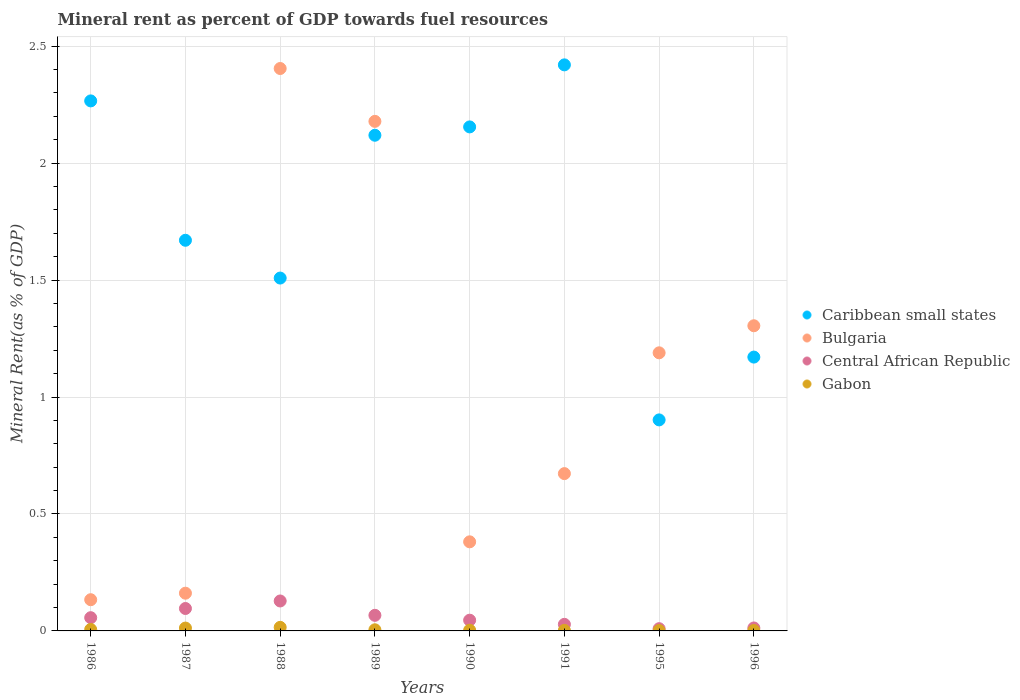How many different coloured dotlines are there?
Provide a succinct answer. 4. Is the number of dotlines equal to the number of legend labels?
Ensure brevity in your answer.  Yes. What is the mineral rent in Bulgaria in 1991?
Offer a terse response. 0.67. Across all years, what is the maximum mineral rent in Bulgaria?
Your response must be concise. 2.4. Across all years, what is the minimum mineral rent in Bulgaria?
Give a very brief answer. 0.13. What is the total mineral rent in Central African Republic in the graph?
Ensure brevity in your answer.  0.44. What is the difference between the mineral rent in Bulgaria in 1988 and that in 1991?
Give a very brief answer. 1.73. What is the difference between the mineral rent in Bulgaria in 1988 and the mineral rent in Gabon in 1996?
Ensure brevity in your answer.  2.4. What is the average mineral rent in Gabon per year?
Make the answer very short. 0.01. In the year 1989, what is the difference between the mineral rent in Gabon and mineral rent in Central African Republic?
Your answer should be compact. -0.06. In how many years, is the mineral rent in Gabon greater than 1.3 %?
Make the answer very short. 0. What is the ratio of the mineral rent in Caribbean small states in 1995 to that in 1996?
Ensure brevity in your answer.  0.77. Is the mineral rent in Caribbean small states in 1990 less than that in 1996?
Your response must be concise. No. What is the difference between the highest and the second highest mineral rent in Central African Republic?
Keep it short and to the point. 0.03. What is the difference between the highest and the lowest mineral rent in Central African Republic?
Your answer should be very brief. 0.12. Is it the case that in every year, the sum of the mineral rent in Bulgaria and mineral rent in Central African Republic  is greater than the mineral rent in Gabon?
Ensure brevity in your answer.  Yes. Is the mineral rent in Gabon strictly less than the mineral rent in Bulgaria over the years?
Provide a succinct answer. Yes. How many years are there in the graph?
Your response must be concise. 8. What is the difference between two consecutive major ticks on the Y-axis?
Give a very brief answer. 0.5. Are the values on the major ticks of Y-axis written in scientific E-notation?
Keep it short and to the point. No. Does the graph contain grids?
Offer a terse response. Yes. How many legend labels are there?
Ensure brevity in your answer.  4. How are the legend labels stacked?
Your answer should be very brief. Vertical. What is the title of the graph?
Your answer should be very brief. Mineral rent as percent of GDP towards fuel resources. Does "Yemen, Rep." appear as one of the legend labels in the graph?
Provide a succinct answer. No. What is the label or title of the Y-axis?
Your answer should be very brief. Mineral Rent(as % of GDP). What is the Mineral Rent(as % of GDP) in Caribbean small states in 1986?
Give a very brief answer. 2.27. What is the Mineral Rent(as % of GDP) of Bulgaria in 1986?
Your response must be concise. 0.13. What is the Mineral Rent(as % of GDP) in Central African Republic in 1986?
Your answer should be compact. 0.06. What is the Mineral Rent(as % of GDP) in Gabon in 1986?
Keep it short and to the point. 0.01. What is the Mineral Rent(as % of GDP) in Caribbean small states in 1987?
Make the answer very short. 1.67. What is the Mineral Rent(as % of GDP) in Bulgaria in 1987?
Your answer should be compact. 0.16. What is the Mineral Rent(as % of GDP) in Central African Republic in 1987?
Keep it short and to the point. 0.1. What is the Mineral Rent(as % of GDP) of Gabon in 1987?
Offer a very short reply. 0.01. What is the Mineral Rent(as % of GDP) of Caribbean small states in 1988?
Make the answer very short. 1.51. What is the Mineral Rent(as % of GDP) of Bulgaria in 1988?
Your answer should be very brief. 2.4. What is the Mineral Rent(as % of GDP) in Central African Republic in 1988?
Your answer should be very brief. 0.13. What is the Mineral Rent(as % of GDP) in Gabon in 1988?
Give a very brief answer. 0.02. What is the Mineral Rent(as % of GDP) in Caribbean small states in 1989?
Keep it short and to the point. 2.12. What is the Mineral Rent(as % of GDP) of Bulgaria in 1989?
Give a very brief answer. 2.18. What is the Mineral Rent(as % of GDP) of Central African Republic in 1989?
Your answer should be very brief. 0.07. What is the Mineral Rent(as % of GDP) in Gabon in 1989?
Keep it short and to the point. 0. What is the Mineral Rent(as % of GDP) of Caribbean small states in 1990?
Provide a short and direct response. 2.15. What is the Mineral Rent(as % of GDP) in Bulgaria in 1990?
Your response must be concise. 0.38. What is the Mineral Rent(as % of GDP) in Central African Republic in 1990?
Your response must be concise. 0.05. What is the Mineral Rent(as % of GDP) of Gabon in 1990?
Your response must be concise. 0. What is the Mineral Rent(as % of GDP) of Caribbean small states in 1991?
Offer a very short reply. 2.42. What is the Mineral Rent(as % of GDP) in Bulgaria in 1991?
Provide a succinct answer. 0.67. What is the Mineral Rent(as % of GDP) of Central African Republic in 1991?
Provide a succinct answer. 0.03. What is the Mineral Rent(as % of GDP) of Gabon in 1991?
Provide a succinct answer. 0. What is the Mineral Rent(as % of GDP) of Caribbean small states in 1995?
Your response must be concise. 0.9. What is the Mineral Rent(as % of GDP) in Bulgaria in 1995?
Provide a short and direct response. 1.19. What is the Mineral Rent(as % of GDP) of Central African Republic in 1995?
Keep it short and to the point. 0.01. What is the Mineral Rent(as % of GDP) in Gabon in 1995?
Provide a short and direct response. 0. What is the Mineral Rent(as % of GDP) of Caribbean small states in 1996?
Keep it short and to the point. 1.17. What is the Mineral Rent(as % of GDP) of Bulgaria in 1996?
Ensure brevity in your answer.  1.3. What is the Mineral Rent(as % of GDP) in Central African Republic in 1996?
Your response must be concise. 0.01. What is the Mineral Rent(as % of GDP) of Gabon in 1996?
Give a very brief answer. 0. Across all years, what is the maximum Mineral Rent(as % of GDP) in Caribbean small states?
Ensure brevity in your answer.  2.42. Across all years, what is the maximum Mineral Rent(as % of GDP) in Bulgaria?
Offer a terse response. 2.4. Across all years, what is the maximum Mineral Rent(as % of GDP) in Central African Republic?
Make the answer very short. 0.13. Across all years, what is the maximum Mineral Rent(as % of GDP) of Gabon?
Make the answer very short. 0.02. Across all years, what is the minimum Mineral Rent(as % of GDP) in Caribbean small states?
Your answer should be compact. 0.9. Across all years, what is the minimum Mineral Rent(as % of GDP) of Bulgaria?
Keep it short and to the point. 0.13. Across all years, what is the minimum Mineral Rent(as % of GDP) of Central African Republic?
Keep it short and to the point. 0.01. Across all years, what is the minimum Mineral Rent(as % of GDP) of Gabon?
Give a very brief answer. 0. What is the total Mineral Rent(as % of GDP) of Caribbean small states in the graph?
Ensure brevity in your answer.  14.21. What is the total Mineral Rent(as % of GDP) in Bulgaria in the graph?
Offer a very short reply. 8.43. What is the total Mineral Rent(as % of GDP) in Central African Republic in the graph?
Make the answer very short. 0.44. What is the total Mineral Rent(as % of GDP) in Gabon in the graph?
Make the answer very short. 0.05. What is the difference between the Mineral Rent(as % of GDP) in Caribbean small states in 1986 and that in 1987?
Provide a short and direct response. 0.6. What is the difference between the Mineral Rent(as % of GDP) in Bulgaria in 1986 and that in 1987?
Ensure brevity in your answer.  -0.03. What is the difference between the Mineral Rent(as % of GDP) in Central African Republic in 1986 and that in 1987?
Give a very brief answer. -0.04. What is the difference between the Mineral Rent(as % of GDP) of Gabon in 1986 and that in 1987?
Offer a very short reply. -0.01. What is the difference between the Mineral Rent(as % of GDP) of Caribbean small states in 1986 and that in 1988?
Give a very brief answer. 0.76. What is the difference between the Mineral Rent(as % of GDP) of Bulgaria in 1986 and that in 1988?
Offer a very short reply. -2.27. What is the difference between the Mineral Rent(as % of GDP) in Central African Republic in 1986 and that in 1988?
Ensure brevity in your answer.  -0.07. What is the difference between the Mineral Rent(as % of GDP) of Gabon in 1986 and that in 1988?
Your response must be concise. -0.01. What is the difference between the Mineral Rent(as % of GDP) of Caribbean small states in 1986 and that in 1989?
Your response must be concise. 0.15. What is the difference between the Mineral Rent(as % of GDP) in Bulgaria in 1986 and that in 1989?
Provide a succinct answer. -2.05. What is the difference between the Mineral Rent(as % of GDP) of Central African Republic in 1986 and that in 1989?
Make the answer very short. -0.01. What is the difference between the Mineral Rent(as % of GDP) of Gabon in 1986 and that in 1989?
Offer a terse response. 0. What is the difference between the Mineral Rent(as % of GDP) in Caribbean small states in 1986 and that in 1990?
Keep it short and to the point. 0.11. What is the difference between the Mineral Rent(as % of GDP) in Bulgaria in 1986 and that in 1990?
Offer a terse response. -0.25. What is the difference between the Mineral Rent(as % of GDP) in Central African Republic in 1986 and that in 1990?
Your answer should be very brief. 0.01. What is the difference between the Mineral Rent(as % of GDP) in Gabon in 1986 and that in 1990?
Your answer should be compact. 0. What is the difference between the Mineral Rent(as % of GDP) of Caribbean small states in 1986 and that in 1991?
Offer a terse response. -0.15. What is the difference between the Mineral Rent(as % of GDP) in Bulgaria in 1986 and that in 1991?
Provide a succinct answer. -0.54. What is the difference between the Mineral Rent(as % of GDP) of Central African Republic in 1986 and that in 1991?
Give a very brief answer. 0.03. What is the difference between the Mineral Rent(as % of GDP) in Gabon in 1986 and that in 1991?
Ensure brevity in your answer.  0. What is the difference between the Mineral Rent(as % of GDP) of Caribbean small states in 1986 and that in 1995?
Provide a succinct answer. 1.36. What is the difference between the Mineral Rent(as % of GDP) of Bulgaria in 1986 and that in 1995?
Keep it short and to the point. -1.06. What is the difference between the Mineral Rent(as % of GDP) in Central African Republic in 1986 and that in 1995?
Offer a very short reply. 0.05. What is the difference between the Mineral Rent(as % of GDP) of Gabon in 1986 and that in 1995?
Give a very brief answer. 0. What is the difference between the Mineral Rent(as % of GDP) of Caribbean small states in 1986 and that in 1996?
Give a very brief answer. 1.1. What is the difference between the Mineral Rent(as % of GDP) in Bulgaria in 1986 and that in 1996?
Provide a short and direct response. -1.17. What is the difference between the Mineral Rent(as % of GDP) of Central African Republic in 1986 and that in 1996?
Your answer should be compact. 0.04. What is the difference between the Mineral Rent(as % of GDP) of Gabon in 1986 and that in 1996?
Offer a very short reply. 0. What is the difference between the Mineral Rent(as % of GDP) in Caribbean small states in 1987 and that in 1988?
Your answer should be very brief. 0.16. What is the difference between the Mineral Rent(as % of GDP) in Bulgaria in 1987 and that in 1988?
Keep it short and to the point. -2.24. What is the difference between the Mineral Rent(as % of GDP) of Central African Republic in 1987 and that in 1988?
Your answer should be very brief. -0.03. What is the difference between the Mineral Rent(as % of GDP) of Gabon in 1987 and that in 1988?
Ensure brevity in your answer.  -0. What is the difference between the Mineral Rent(as % of GDP) in Caribbean small states in 1987 and that in 1989?
Give a very brief answer. -0.45. What is the difference between the Mineral Rent(as % of GDP) of Bulgaria in 1987 and that in 1989?
Your answer should be compact. -2.02. What is the difference between the Mineral Rent(as % of GDP) of Central African Republic in 1987 and that in 1989?
Your answer should be very brief. 0.03. What is the difference between the Mineral Rent(as % of GDP) in Gabon in 1987 and that in 1989?
Give a very brief answer. 0.01. What is the difference between the Mineral Rent(as % of GDP) of Caribbean small states in 1987 and that in 1990?
Make the answer very short. -0.48. What is the difference between the Mineral Rent(as % of GDP) of Bulgaria in 1987 and that in 1990?
Provide a succinct answer. -0.22. What is the difference between the Mineral Rent(as % of GDP) in Central African Republic in 1987 and that in 1990?
Make the answer very short. 0.05. What is the difference between the Mineral Rent(as % of GDP) of Gabon in 1987 and that in 1990?
Provide a short and direct response. 0.01. What is the difference between the Mineral Rent(as % of GDP) of Caribbean small states in 1987 and that in 1991?
Offer a very short reply. -0.75. What is the difference between the Mineral Rent(as % of GDP) of Bulgaria in 1987 and that in 1991?
Provide a succinct answer. -0.51. What is the difference between the Mineral Rent(as % of GDP) in Central African Republic in 1987 and that in 1991?
Offer a very short reply. 0.07. What is the difference between the Mineral Rent(as % of GDP) of Gabon in 1987 and that in 1991?
Make the answer very short. 0.01. What is the difference between the Mineral Rent(as % of GDP) in Caribbean small states in 1987 and that in 1995?
Provide a succinct answer. 0.77. What is the difference between the Mineral Rent(as % of GDP) of Bulgaria in 1987 and that in 1995?
Your answer should be compact. -1.03. What is the difference between the Mineral Rent(as % of GDP) of Central African Republic in 1987 and that in 1995?
Give a very brief answer. 0.09. What is the difference between the Mineral Rent(as % of GDP) in Gabon in 1987 and that in 1995?
Your answer should be compact. 0.01. What is the difference between the Mineral Rent(as % of GDP) in Caribbean small states in 1987 and that in 1996?
Provide a short and direct response. 0.5. What is the difference between the Mineral Rent(as % of GDP) in Bulgaria in 1987 and that in 1996?
Your answer should be very brief. -1.14. What is the difference between the Mineral Rent(as % of GDP) of Central African Republic in 1987 and that in 1996?
Your response must be concise. 0.08. What is the difference between the Mineral Rent(as % of GDP) in Gabon in 1987 and that in 1996?
Offer a terse response. 0.01. What is the difference between the Mineral Rent(as % of GDP) in Caribbean small states in 1988 and that in 1989?
Your answer should be very brief. -0.61. What is the difference between the Mineral Rent(as % of GDP) of Bulgaria in 1988 and that in 1989?
Your response must be concise. 0.23. What is the difference between the Mineral Rent(as % of GDP) in Central African Republic in 1988 and that in 1989?
Your response must be concise. 0.06. What is the difference between the Mineral Rent(as % of GDP) in Gabon in 1988 and that in 1989?
Your response must be concise. 0.01. What is the difference between the Mineral Rent(as % of GDP) of Caribbean small states in 1988 and that in 1990?
Offer a very short reply. -0.65. What is the difference between the Mineral Rent(as % of GDP) of Bulgaria in 1988 and that in 1990?
Provide a short and direct response. 2.02. What is the difference between the Mineral Rent(as % of GDP) of Central African Republic in 1988 and that in 1990?
Your response must be concise. 0.08. What is the difference between the Mineral Rent(as % of GDP) in Gabon in 1988 and that in 1990?
Your response must be concise. 0.01. What is the difference between the Mineral Rent(as % of GDP) of Caribbean small states in 1988 and that in 1991?
Your answer should be compact. -0.91. What is the difference between the Mineral Rent(as % of GDP) in Bulgaria in 1988 and that in 1991?
Ensure brevity in your answer.  1.73. What is the difference between the Mineral Rent(as % of GDP) in Central African Republic in 1988 and that in 1991?
Provide a succinct answer. 0.1. What is the difference between the Mineral Rent(as % of GDP) of Gabon in 1988 and that in 1991?
Offer a very short reply. 0.01. What is the difference between the Mineral Rent(as % of GDP) of Caribbean small states in 1988 and that in 1995?
Offer a terse response. 0.61. What is the difference between the Mineral Rent(as % of GDP) of Bulgaria in 1988 and that in 1995?
Provide a succinct answer. 1.22. What is the difference between the Mineral Rent(as % of GDP) of Central African Republic in 1988 and that in 1995?
Ensure brevity in your answer.  0.12. What is the difference between the Mineral Rent(as % of GDP) of Gabon in 1988 and that in 1995?
Give a very brief answer. 0.01. What is the difference between the Mineral Rent(as % of GDP) in Caribbean small states in 1988 and that in 1996?
Make the answer very short. 0.34. What is the difference between the Mineral Rent(as % of GDP) of Bulgaria in 1988 and that in 1996?
Your response must be concise. 1.1. What is the difference between the Mineral Rent(as % of GDP) of Central African Republic in 1988 and that in 1996?
Your answer should be very brief. 0.12. What is the difference between the Mineral Rent(as % of GDP) in Gabon in 1988 and that in 1996?
Your answer should be compact. 0.01. What is the difference between the Mineral Rent(as % of GDP) in Caribbean small states in 1989 and that in 1990?
Keep it short and to the point. -0.04. What is the difference between the Mineral Rent(as % of GDP) of Bulgaria in 1989 and that in 1990?
Make the answer very short. 1.8. What is the difference between the Mineral Rent(as % of GDP) of Central African Republic in 1989 and that in 1990?
Give a very brief answer. 0.02. What is the difference between the Mineral Rent(as % of GDP) in Gabon in 1989 and that in 1990?
Provide a short and direct response. 0. What is the difference between the Mineral Rent(as % of GDP) in Caribbean small states in 1989 and that in 1991?
Keep it short and to the point. -0.3. What is the difference between the Mineral Rent(as % of GDP) in Bulgaria in 1989 and that in 1991?
Offer a very short reply. 1.51. What is the difference between the Mineral Rent(as % of GDP) of Central African Republic in 1989 and that in 1991?
Provide a succinct answer. 0.04. What is the difference between the Mineral Rent(as % of GDP) in Gabon in 1989 and that in 1991?
Ensure brevity in your answer.  0. What is the difference between the Mineral Rent(as % of GDP) of Caribbean small states in 1989 and that in 1995?
Provide a succinct answer. 1.22. What is the difference between the Mineral Rent(as % of GDP) of Bulgaria in 1989 and that in 1995?
Give a very brief answer. 0.99. What is the difference between the Mineral Rent(as % of GDP) of Central African Republic in 1989 and that in 1995?
Your answer should be compact. 0.06. What is the difference between the Mineral Rent(as % of GDP) in Gabon in 1989 and that in 1995?
Provide a succinct answer. 0. What is the difference between the Mineral Rent(as % of GDP) of Caribbean small states in 1989 and that in 1996?
Your answer should be very brief. 0.95. What is the difference between the Mineral Rent(as % of GDP) in Bulgaria in 1989 and that in 1996?
Provide a short and direct response. 0.87. What is the difference between the Mineral Rent(as % of GDP) of Central African Republic in 1989 and that in 1996?
Provide a succinct answer. 0.05. What is the difference between the Mineral Rent(as % of GDP) in Gabon in 1989 and that in 1996?
Make the answer very short. 0. What is the difference between the Mineral Rent(as % of GDP) in Caribbean small states in 1990 and that in 1991?
Make the answer very short. -0.27. What is the difference between the Mineral Rent(as % of GDP) of Bulgaria in 1990 and that in 1991?
Your response must be concise. -0.29. What is the difference between the Mineral Rent(as % of GDP) of Central African Republic in 1990 and that in 1991?
Provide a short and direct response. 0.02. What is the difference between the Mineral Rent(as % of GDP) in Gabon in 1990 and that in 1991?
Provide a short and direct response. 0. What is the difference between the Mineral Rent(as % of GDP) of Caribbean small states in 1990 and that in 1995?
Provide a short and direct response. 1.25. What is the difference between the Mineral Rent(as % of GDP) in Bulgaria in 1990 and that in 1995?
Keep it short and to the point. -0.81. What is the difference between the Mineral Rent(as % of GDP) of Central African Republic in 1990 and that in 1995?
Offer a very short reply. 0.04. What is the difference between the Mineral Rent(as % of GDP) in Gabon in 1990 and that in 1995?
Keep it short and to the point. 0. What is the difference between the Mineral Rent(as % of GDP) in Caribbean small states in 1990 and that in 1996?
Keep it short and to the point. 0.98. What is the difference between the Mineral Rent(as % of GDP) of Bulgaria in 1990 and that in 1996?
Your answer should be very brief. -0.92. What is the difference between the Mineral Rent(as % of GDP) in Central African Republic in 1990 and that in 1996?
Offer a terse response. 0.03. What is the difference between the Mineral Rent(as % of GDP) of Gabon in 1990 and that in 1996?
Provide a short and direct response. 0. What is the difference between the Mineral Rent(as % of GDP) of Caribbean small states in 1991 and that in 1995?
Offer a very short reply. 1.52. What is the difference between the Mineral Rent(as % of GDP) of Bulgaria in 1991 and that in 1995?
Offer a very short reply. -0.52. What is the difference between the Mineral Rent(as % of GDP) of Central African Republic in 1991 and that in 1995?
Your response must be concise. 0.02. What is the difference between the Mineral Rent(as % of GDP) in Gabon in 1991 and that in 1995?
Provide a succinct answer. 0. What is the difference between the Mineral Rent(as % of GDP) of Caribbean small states in 1991 and that in 1996?
Make the answer very short. 1.25. What is the difference between the Mineral Rent(as % of GDP) in Bulgaria in 1991 and that in 1996?
Give a very brief answer. -0.63. What is the difference between the Mineral Rent(as % of GDP) of Central African Republic in 1991 and that in 1996?
Make the answer very short. 0.02. What is the difference between the Mineral Rent(as % of GDP) of Gabon in 1991 and that in 1996?
Provide a succinct answer. 0. What is the difference between the Mineral Rent(as % of GDP) in Caribbean small states in 1995 and that in 1996?
Make the answer very short. -0.27. What is the difference between the Mineral Rent(as % of GDP) in Bulgaria in 1995 and that in 1996?
Make the answer very short. -0.12. What is the difference between the Mineral Rent(as % of GDP) of Central African Republic in 1995 and that in 1996?
Ensure brevity in your answer.  -0. What is the difference between the Mineral Rent(as % of GDP) of Gabon in 1995 and that in 1996?
Provide a short and direct response. -0. What is the difference between the Mineral Rent(as % of GDP) of Caribbean small states in 1986 and the Mineral Rent(as % of GDP) of Bulgaria in 1987?
Give a very brief answer. 2.1. What is the difference between the Mineral Rent(as % of GDP) in Caribbean small states in 1986 and the Mineral Rent(as % of GDP) in Central African Republic in 1987?
Your answer should be compact. 2.17. What is the difference between the Mineral Rent(as % of GDP) in Caribbean small states in 1986 and the Mineral Rent(as % of GDP) in Gabon in 1987?
Your answer should be very brief. 2.25. What is the difference between the Mineral Rent(as % of GDP) of Bulgaria in 1986 and the Mineral Rent(as % of GDP) of Central African Republic in 1987?
Provide a succinct answer. 0.04. What is the difference between the Mineral Rent(as % of GDP) in Bulgaria in 1986 and the Mineral Rent(as % of GDP) in Gabon in 1987?
Your response must be concise. 0.12. What is the difference between the Mineral Rent(as % of GDP) of Central African Republic in 1986 and the Mineral Rent(as % of GDP) of Gabon in 1987?
Keep it short and to the point. 0.04. What is the difference between the Mineral Rent(as % of GDP) of Caribbean small states in 1986 and the Mineral Rent(as % of GDP) of Bulgaria in 1988?
Your answer should be compact. -0.14. What is the difference between the Mineral Rent(as % of GDP) in Caribbean small states in 1986 and the Mineral Rent(as % of GDP) in Central African Republic in 1988?
Offer a terse response. 2.14. What is the difference between the Mineral Rent(as % of GDP) in Caribbean small states in 1986 and the Mineral Rent(as % of GDP) in Gabon in 1988?
Give a very brief answer. 2.25. What is the difference between the Mineral Rent(as % of GDP) in Bulgaria in 1986 and the Mineral Rent(as % of GDP) in Central African Republic in 1988?
Keep it short and to the point. 0.01. What is the difference between the Mineral Rent(as % of GDP) of Bulgaria in 1986 and the Mineral Rent(as % of GDP) of Gabon in 1988?
Your answer should be very brief. 0.12. What is the difference between the Mineral Rent(as % of GDP) of Central African Republic in 1986 and the Mineral Rent(as % of GDP) of Gabon in 1988?
Give a very brief answer. 0.04. What is the difference between the Mineral Rent(as % of GDP) of Caribbean small states in 1986 and the Mineral Rent(as % of GDP) of Bulgaria in 1989?
Give a very brief answer. 0.09. What is the difference between the Mineral Rent(as % of GDP) of Caribbean small states in 1986 and the Mineral Rent(as % of GDP) of Central African Republic in 1989?
Ensure brevity in your answer.  2.2. What is the difference between the Mineral Rent(as % of GDP) in Caribbean small states in 1986 and the Mineral Rent(as % of GDP) in Gabon in 1989?
Provide a succinct answer. 2.26. What is the difference between the Mineral Rent(as % of GDP) of Bulgaria in 1986 and the Mineral Rent(as % of GDP) of Central African Republic in 1989?
Provide a short and direct response. 0.07. What is the difference between the Mineral Rent(as % of GDP) in Bulgaria in 1986 and the Mineral Rent(as % of GDP) in Gabon in 1989?
Your answer should be compact. 0.13. What is the difference between the Mineral Rent(as % of GDP) of Central African Republic in 1986 and the Mineral Rent(as % of GDP) of Gabon in 1989?
Ensure brevity in your answer.  0.05. What is the difference between the Mineral Rent(as % of GDP) of Caribbean small states in 1986 and the Mineral Rent(as % of GDP) of Bulgaria in 1990?
Ensure brevity in your answer.  1.89. What is the difference between the Mineral Rent(as % of GDP) of Caribbean small states in 1986 and the Mineral Rent(as % of GDP) of Central African Republic in 1990?
Provide a succinct answer. 2.22. What is the difference between the Mineral Rent(as % of GDP) of Caribbean small states in 1986 and the Mineral Rent(as % of GDP) of Gabon in 1990?
Keep it short and to the point. 2.26. What is the difference between the Mineral Rent(as % of GDP) in Bulgaria in 1986 and the Mineral Rent(as % of GDP) in Central African Republic in 1990?
Offer a terse response. 0.09. What is the difference between the Mineral Rent(as % of GDP) in Bulgaria in 1986 and the Mineral Rent(as % of GDP) in Gabon in 1990?
Your response must be concise. 0.13. What is the difference between the Mineral Rent(as % of GDP) in Central African Republic in 1986 and the Mineral Rent(as % of GDP) in Gabon in 1990?
Offer a very short reply. 0.05. What is the difference between the Mineral Rent(as % of GDP) in Caribbean small states in 1986 and the Mineral Rent(as % of GDP) in Bulgaria in 1991?
Your response must be concise. 1.59. What is the difference between the Mineral Rent(as % of GDP) in Caribbean small states in 1986 and the Mineral Rent(as % of GDP) in Central African Republic in 1991?
Provide a short and direct response. 2.24. What is the difference between the Mineral Rent(as % of GDP) of Caribbean small states in 1986 and the Mineral Rent(as % of GDP) of Gabon in 1991?
Keep it short and to the point. 2.26. What is the difference between the Mineral Rent(as % of GDP) of Bulgaria in 1986 and the Mineral Rent(as % of GDP) of Central African Republic in 1991?
Ensure brevity in your answer.  0.11. What is the difference between the Mineral Rent(as % of GDP) in Bulgaria in 1986 and the Mineral Rent(as % of GDP) in Gabon in 1991?
Ensure brevity in your answer.  0.13. What is the difference between the Mineral Rent(as % of GDP) of Central African Republic in 1986 and the Mineral Rent(as % of GDP) of Gabon in 1991?
Your answer should be compact. 0.05. What is the difference between the Mineral Rent(as % of GDP) of Caribbean small states in 1986 and the Mineral Rent(as % of GDP) of Bulgaria in 1995?
Provide a succinct answer. 1.08. What is the difference between the Mineral Rent(as % of GDP) in Caribbean small states in 1986 and the Mineral Rent(as % of GDP) in Central African Republic in 1995?
Make the answer very short. 2.26. What is the difference between the Mineral Rent(as % of GDP) of Caribbean small states in 1986 and the Mineral Rent(as % of GDP) of Gabon in 1995?
Offer a very short reply. 2.26. What is the difference between the Mineral Rent(as % of GDP) in Bulgaria in 1986 and the Mineral Rent(as % of GDP) in Central African Republic in 1995?
Give a very brief answer. 0.12. What is the difference between the Mineral Rent(as % of GDP) in Bulgaria in 1986 and the Mineral Rent(as % of GDP) in Gabon in 1995?
Your answer should be very brief. 0.13. What is the difference between the Mineral Rent(as % of GDP) of Central African Republic in 1986 and the Mineral Rent(as % of GDP) of Gabon in 1995?
Your response must be concise. 0.06. What is the difference between the Mineral Rent(as % of GDP) in Caribbean small states in 1986 and the Mineral Rent(as % of GDP) in Bulgaria in 1996?
Offer a very short reply. 0.96. What is the difference between the Mineral Rent(as % of GDP) of Caribbean small states in 1986 and the Mineral Rent(as % of GDP) of Central African Republic in 1996?
Your answer should be compact. 2.25. What is the difference between the Mineral Rent(as % of GDP) of Caribbean small states in 1986 and the Mineral Rent(as % of GDP) of Gabon in 1996?
Provide a short and direct response. 2.26. What is the difference between the Mineral Rent(as % of GDP) in Bulgaria in 1986 and the Mineral Rent(as % of GDP) in Central African Republic in 1996?
Give a very brief answer. 0.12. What is the difference between the Mineral Rent(as % of GDP) in Bulgaria in 1986 and the Mineral Rent(as % of GDP) in Gabon in 1996?
Keep it short and to the point. 0.13. What is the difference between the Mineral Rent(as % of GDP) in Central African Republic in 1986 and the Mineral Rent(as % of GDP) in Gabon in 1996?
Give a very brief answer. 0.05. What is the difference between the Mineral Rent(as % of GDP) in Caribbean small states in 1987 and the Mineral Rent(as % of GDP) in Bulgaria in 1988?
Make the answer very short. -0.73. What is the difference between the Mineral Rent(as % of GDP) of Caribbean small states in 1987 and the Mineral Rent(as % of GDP) of Central African Republic in 1988?
Your answer should be very brief. 1.54. What is the difference between the Mineral Rent(as % of GDP) in Caribbean small states in 1987 and the Mineral Rent(as % of GDP) in Gabon in 1988?
Give a very brief answer. 1.66. What is the difference between the Mineral Rent(as % of GDP) of Bulgaria in 1987 and the Mineral Rent(as % of GDP) of Gabon in 1988?
Your answer should be compact. 0.15. What is the difference between the Mineral Rent(as % of GDP) of Central African Republic in 1987 and the Mineral Rent(as % of GDP) of Gabon in 1988?
Offer a terse response. 0.08. What is the difference between the Mineral Rent(as % of GDP) in Caribbean small states in 1987 and the Mineral Rent(as % of GDP) in Bulgaria in 1989?
Your answer should be very brief. -0.51. What is the difference between the Mineral Rent(as % of GDP) of Caribbean small states in 1987 and the Mineral Rent(as % of GDP) of Central African Republic in 1989?
Your answer should be compact. 1.6. What is the difference between the Mineral Rent(as % of GDP) in Caribbean small states in 1987 and the Mineral Rent(as % of GDP) in Gabon in 1989?
Your answer should be compact. 1.67. What is the difference between the Mineral Rent(as % of GDP) of Bulgaria in 1987 and the Mineral Rent(as % of GDP) of Central African Republic in 1989?
Ensure brevity in your answer.  0.09. What is the difference between the Mineral Rent(as % of GDP) of Bulgaria in 1987 and the Mineral Rent(as % of GDP) of Gabon in 1989?
Your answer should be very brief. 0.16. What is the difference between the Mineral Rent(as % of GDP) of Central African Republic in 1987 and the Mineral Rent(as % of GDP) of Gabon in 1989?
Ensure brevity in your answer.  0.09. What is the difference between the Mineral Rent(as % of GDP) in Caribbean small states in 1987 and the Mineral Rent(as % of GDP) in Bulgaria in 1990?
Give a very brief answer. 1.29. What is the difference between the Mineral Rent(as % of GDP) of Caribbean small states in 1987 and the Mineral Rent(as % of GDP) of Central African Republic in 1990?
Offer a very short reply. 1.62. What is the difference between the Mineral Rent(as % of GDP) in Caribbean small states in 1987 and the Mineral Rent(as % of GDP) in Gabon in 1990?
Offer a terse response. 1.67. What is the difference between the Mineral Rent(as % of GDP) in Bulgaria in 1987 and the Mineral Rent(as % of GDP) in Central African Republic in 1990?
Offer a terse response. 0.12. What is the difference between the Mineral Rent(as % of GDP) in Bulgaria in 1987 and the Mineral Rent(as % of GDP) in Gabon in 1990?
Offer a terse response. 0.16. What is the difference between the Mineral Rent(as % of GDP) of Central African Republic in 1987 and the Mineral Rent(as % of GDP) of Gabon in 1990?
Offer a terse response. 0.09. What is the difference between the Mineral Rent(as % of GDP) in Caribbean small states in 1987 and the Mineral Rent(as % of GDP) in Central African Republic in 1991?
Offer a terse response. 1.64. What is the difference between the Mineral Rent(as % of GDP) of Caribbean small states in 1987 and the Mineral Rent(as % of GDP) of Gabon in 1991?
Make the answer very short. 1.67. What is the difference between the Mineral Rent(as % of GDP) of Bulgaria in 1987 and the Mineral Rent(as % of GDP) of Central African Republic in 1991?
Offer a terse response. 0.13. What is the difference between the Mineral Rent(as % of GDP) in Bulgaria in 1987 and the Mineral Rent(as % of GDP) in Gabon in 1991?
Ensure brevity in your answer.  0.16. What is the difference between the Mineral Rent(as % of GDP) of Central African Republic in 1987 and the Mineral Rent(as % of GDP) of Gabon in 1991?
Your answer should be very brief. 0.09. What is the difference between the Mineral Rent(as % of GDP) in Caribbean small states in 1987 and the Mineral Rent(as % of GDP) in Bulgaria in 1995?
Ensure brevity in your answer.  0.48. What is the difference between the Mineral Rent(as % of GDP) in Caribbean small states in 1987 and the Mineral Rent(as % of GDP) in Central African Republic in 1995?
Keep it short and to the point. 1.66. What is the difference between the Mineral Rent(as % of GDP) in Caribbean small states in 1987 and the Mineral Rent(as % of GDP) in Gabon in 1995?
Your response must be concise. 1.67. What is the difference between the Mineral Rent(as % of GDP) in Bulgaria in 1987 and the Mineral Rent(as % of GDP) in Central African Republic in 1995?
Offer a very short reply. 0.15. What is the difference between the Mineral Rent(as % of GDP) of Bulgaria in 1987 and the Mineral Rent(as % of GDP) of Gabon in 1995?
Provide a succinct answer. 0.16. What is the difference between the Mineral Rent(as % of GDP) of Central African Republic in 1987 and the Mineral Rent(as % of GDP) of Gabon in 1995?
Keep it short and to the point. 0.09. What is the difference between the Mineral Rent(as % of GDP) in Caribbean small states in 1987 and the Mineral Rent(as % of GDP) in Bulgaria in 1996?
Offer a terse response. 0.37. What is the difference between the Mineral Rent(as % of GDP) of Caribbean small states in 1987 and the Mineral Rent(as % of GDP) of Central African Republic in 1996?
Your answer should be compact. 1.66. What is the difference between the Mineral Rent(as % of GDP) in Caribbean small states in 1987 and the Mineral Rent(as % of GDP) in Gabon in 1996?
Provide a short and direct response. 1.67. What is the difference between the Mineral Rent(as % of GDP) in Bulgaria in 1987 and the Mineral Rent(as % of GDP) in Central African Republic in 1996?
Offer a very short reply. 0.15. What is the difference between the Mineral Rent(as % of GDP) in Bulgaria in 1987 and the Mineral Rent(as % of GDP) in Gabon in 1996?
Your response must be concise. 0.16. What is the difference between the Mineral Rent(as % of GDP) in Central African Republic in 1987 and the Mineral Rent(as % of GDP) in Gabon in 1996?
Your answer should be very brief. 0.09. What is the difference between the Mineral Rent(as % of GDP) in Caribbean small states in 1988 and the Mineral Rent(as % of GDP) in Bulgaria in 1989?
Keep it short and to the point. -0.67. What is the difference between the Mineral Rent(as % of GDP) in Caribbean small states in 1988 and the Mineral Rent(as % of GDP) in Central African Republic in 1989?
Give a very brief answer. 1.44. What is the difference between the Mineral Rent(as % of GDP) in Caribbean small states in 1988 and the Mineral Rent(as % of GDP) in Gabon in 1989?
Keep it short and to the point. 1.5. What is the difference between the Mineral Rent(as % of GDP) in Bulgaria in 1988 and the Mineral Rent(as % of GDP) in Central African Republic in 1989?
Keep it short and to the point. 2.34. What is the difference between the Mineral Rent(as % of GDP) in Bulgaria in 1988 and the Mineral Rent(as % of GDP) in Gabon in 1989?
Your response must be concise. 2.4. What is the difference between the Mineral Rent(as % of GDP) in Central African Republic in 1988 and the Mineral Rent(as % of GDP) in Gabon in 1989?
Make the answer very short. 0.12. What is the difference between the Mineral Rent(as % of GDP) in Caribbean small states in 1988 and the Mineral Rent(as % of GDP) in Bulgaria in 1990?
Make the answer very short. 1.13. What is the difference between the Mineral Rent(as % of GDP) in Caribbean small states in 1988 and the Mineral Rent(as % of GDP) in Central African Republic in 1990?
Provide a short and direct response. 1.46. What is the difference between the Mineral Rent(as % of GDP) of Caribbean small states in 1988 and the Mineral Rent(as % of GDP) of Gabon in 1990?
Make the answer very short. 1.51. What is the difference between the Mineral Rent(as % of GDP) in Bulgaria in 1988 and the Mineral Rent(as % of GDP) in Central African Republic in 1990?
Give a very brief answer. 2.36. What is the difference between the Mineral Rent(as % of GDP) of Bulgaria in 1988 and the Mineral Rent(as % of GDP) of Gabon in 1990?
Your response must be concise. 2.4. What is the difference between the Mineral Rent(as % of GDP) in Central African Republic in 1988 and the Mineral Rent(as % of GDP) in Gabon in 1990?
Give a very brief answer. 0.13. What is the difference between the Mineral Rent(as % of GDP) of Caribbean small states in 1988 and the Mineral Rent(as % of GDP) of Bulgaria in 1991?
Offer a very short reply. 0.84. What is the difference between the Mineral Rent(as % of GDP) in Caribbean small states in 1988 and the Mineral Rent(as % of GDP) in Central African Republic in 1991?
Your response must be concise. 1.48. What is the difference between the Mineral Rent(as % of GDP) in Caribbean small states in 1988 and the Mineral Rent(as % of GDP) in Gabon in 1991?
Offer a terse response. 1.51. What is the difference between the Mineral Rent(as % of GDP) in Bulgaria in 1988 and the Mineral Rent(as % of GDP) in Central African Republic in 1991?
Offer a very short reply. 2.38. What is the difference between the Mineral Rent(as % of GDP) of Bulgaria in 1988 and the Mineral Rent(as % of GDP) of Gabon in 1991?
Your answer should be compact. 2.4. What is the difference between the Mineral Rent(as % of GDP) in Central African Republic in 1988 and the Mineral Rent(as % of GDP) in Gabon in 1991?
Your response must be concise. 0.13. What is the difference between the Mineral Rent(as % of GDP) of Caribbean small states in 1988 and the Mineral Rent(as % of GDP) of Bulgaria in 1995?
Keep it short and to the point. 0.32. What is the difference between the Mineral Rent(as % of GDP) in Caribbean small states in 1988 and the Mineral Rent(as % of GDP) in Central African Republic in 1995?
Keep it short and to the point. 1.5. What is the difference between the Mineral Rent(as % of GDP) in Caribbean small states in 1988 and the Mineral Rent(as % of GDP) in Gabon in 1995?
Ensure brevity in your answer.  1.51. What is the difference between the Mineral Rent(as % of GDP) in Bulgaria in 1988 and the Mineral Rent(as % of GDP) in Central African Republic in 1995?
Keep it short and to the point. 2.4. What is the difference between the Mineral Rent(as % of GDP) in Bulgaria in 1988 and the Mineral Rent(as % of GDP) in Gabon in 1995?
Give a very brief answer. 2.4. What is the difference between the Mineral Rent(as % of GDP) in Central African Republic in 1988 and the Mineral Rent(as % of GDP) in Gabon in 1995?
Give a very brief answer. 0.13. What is the difference between the Mineral Rent(as % of GDP) of Caribbean small states in 1988 and the Mineral Rent(as % of GDP) of Bulgaria in 1996?
Make the answer very short. 0.2. What is the difference between the Mineral Rent(as % of GDP) in Caribbean small states in 1988 and the Mineral Rent(as % of GDP) in Central African Republic in 1996?
Keep it short and to the point. 1.5. What is the difference between the Mineral Rent(as % of GDP) in Caribbean small states in 1988 and the Mineral Rent(as % of GDP) in Gabon in 1996?
Offer a terse response. 1.51. What is the difference between the Mineral Rent(as % of GDP) in Bulgaria in 1988 and the Mineral Rent(as % of GDP) in Central African Republic in 1996?
Your response must be concise. 2.39. What is the difference between the Mineral Rent(as % of GDP) in Bulgaria in 1988 and the Mineral Rent(as % of GDP) in Gabon in 1996?
Your answer should be very brief. 2.4. What is the difference between the Mineral Rent(as % of GDP) of Central African Republic in 1988 and the Mineral Rent(as % of GDP) of Gabon in 1996?
Give a very brief answer. 0.13. What is the difference between the Mineral Rent(as % of GDP) in Caribbean small states in 1989 and the Mineral Rent(as % of GDP) in Bulgaria in 1990?
Your answer should be very brief. 1.74. What is the difference between the Mineral Rent(as % of GDP) of Caribbean small states in 1989 and the Mineral Rent(as % of GDP) of Central African Republic in 1990?
Offer a very short reply. 2.07. What is the difference between the Mineral Rent(as % of GDP) of Caribbean small states in 1989 and the Mineral Rent(as % of GDP) of Gabon in 1990?
Give a very brief answer. 2.12. What is the difference between the Mineral Rent(as % of GDP) of Bulgaria in 1989 and the Mineral Rent(as % of GDP) of Central African Republic in 1990?
Your answer should be compact. 2.13. What is the difference between the Mineral Rent(as % of GDP) in Bulgaria in 1989 and the Mineral Rent(as % of GDP) in Gabon in 1990?
Offer a terse response. 2.18. What is the difference between the Mineral Rent(as % of GDP) of Central African Republic in 1989 and the Mineral Rent(as % of GDP) of Gabon in 1990?
Offer a very short reply. 0.06. What is the difference between the Mineral Rent(as % of GDP) of Caribbean small states in 1989 and the Mineral Rent(as % of GDP) of Bulgaria in 1991?
Offer a terse response. 1.45. What is the difference between the Mineral Rent(as % of GDP) of Caribbean small states in 1989 and the Mineral Rent(as % of GDP) of Central African Republic in 1991?
Offer a terse response. 2.09. What is the difference between the Mineral Rent(as % of GDP) of Caribbean small states in 1989 and the Mineral Rent(as % of GDP) of Gabon in 1991?
Make the answer very short. 2.12. What is the difference between the Mineral Rent(as % of GDP) in Bulgaria in 1989 and the Mineral Rent(as % of GDP) in Central African Republic in 1991?
Offer a terse response. 2.15. What is the difference between the Mineral Rent(as % of GDP) in Bulgaria in 1989 and the Mineral Rent(as % of GDP) in Gabon in 1991?
Ensure brevity in your answer.  2.18. What is the difference between the Mineral Rent(as % of GDP) in Central African Republic in 1989 and the Mineral Rent(as % of GDP) in Gabon in 1991?
Ensure brevity in your answer.  0.06. What is the difference between the Mineral Rent(as % of GDP) in Caribbean small states in 1989 and the Mineral Rent(as % of GDP) in Bulgaria in 1995?
Your response must be concise. 0.93. What is the difference between the Mineral Rent(as % of GDP) of Caribbean small states in 1989 and the Mineral Rent(as % of GDP) of Central African Republic in 1995?
Offer a very short reply. 2.11. What is the difference between the Mineral Rent(as % of GDP) in Caribbean small states in 1989 and the Mineral Rent(as % of GDP) in Gabon in 1995?
Keep it short and to the point. 2.12. What is the difference between the Mineral Rent(as % of GDP) in Bulgaria in 1989 and the Mineral Rent(as % of GDP) in Central African Republic in 1995?
Your answer should be compact. 2.17. What is the difference between the Mineral Rent(as % of GDP) in Bulgaria in 1989 and the Mineral Rent(as % of GDP) in Gabon in 1995?
Make the answer very short. 2.18. What is the difference between the Mineral Rent(as % of GDP) in Central African Republic in 1989 and the Mineral Rent(as % of GDP) in Gabon in 1995?
Your answer should be very brief. 0.07. What is the difference between the Mineral Rent(as % of GDP) of Caribbean small states in 1989 and the Mineral Rent(as % of GDP) of Bulgaria in 1996?
Provide a succinct answer. 0.81. What is the difference between the Mineral Rent(as % of GDP) of Caribbean small states in 1989 and the Mineral Rent(as % of GDP) of Central African Republic in 1996?
Your answer should be compact. 2.11. What is the difference between the Mineral Rent(as % of GDP) of Caribbean small states in 1989 and the Mineral Rent(as % of GDP) of Gabon in 1996?
Keep it short and to the point. 2.12. What is the difference between the Mineral Rent(as % of GDP) of Bulgaria in 1989 and the Mineral Rent(as % of GDP) of Central African Republic in 1996?
Provide a short and direct response. 2.17. What is the difference between the Mineral Rent(as % of GDP) in Bulgaria in 1989 and the Mineral Rent(as % of GDP) in Gabon in 1996?
Your answer should be very brief. 2.18. What is the difference between the Mineral Rent(as % of GDP) of Central African Republic in 1989 and the Mineral Rent(as % of GDP) of Gabon in 1996?
Offer a terse response. 0.07. What is the difference between the Mineral Rent(as % of GDP) in Caribbean small states in 1990 and the Mineral Rent(as % of GDP) in Bulgaria in 1991?
Offer a terse response. 1.48. What is the difference between the Mineral Rent(as % of GDP) of Caribbean small states in 1990 and the Mineral Rent(as % of GDP) of Central African Republic in 1991?
Offer a terse response. 2.13. What is the difference between the Mineral Rent(as % of GDP) in Caribbean small states in 1990 and the Mineral Rent(as % of GDP) in Gabon in 1991?
Give a very brief answer. 2.15. What is the difference between the Mineral Rent(as % of GDP) in Bulgaria in 1990 and the Mineral Rent(as % of GDP) in Central African Republic in 1991?
Offer a terse response. 0.35. What is the difference between the Mineral Rent(as % of GDP) in Bulgaria in 1990 and the Mineral Rent(as % of GDP) in Gabon in 1991?
Your response must be concise. 0.38. What is the difference between the Mineral Rent(as % of GDP) in Central African Republic in 1990 and the Mineral Rent(as % of GDP) in Gabon in 1991?
Give a very brief answer. 0.04. What is the difference between the Mineral Rent(as % of GDP) of Caribbean small states in 1990 and the Mineral Rent(as % of GDP) of Bulgaria in 1995?
Your answer should be compact. 0.97. What is the difference between the Mineral Rent(as % of GDP) of Caribbean small states in 1990 and the Mineral Rent(as % of GDP) of Central African Republic in 1995?
Keep it short and to the point. 2.15. What is the difference between the Mineral Rent(as % of GDP) in Caribbean small states in 1990 and the Mineral Rent(as % of GDP) in Gabon in 1995?
Your answer should be very brief. 2.15. What is the difference between the Mineral Rent(as % of GDP) of Bulgaria in 1990 and the Mineral Rent(as % of GDP) of Central African Republic in 1995?
Provide a short and direct response. 0.37. What is the difference between the Mineral Rent(as % of GDP) of Bulgaria in 1990 and the Mineral Rent(as % of GDP) of Gabon in 1995?
Offer a terse response. 0.38. What is the difference between the Mineral Rent(as % of GDP) of Central African Republic in 1990 and the Mineral Rent(as % of GDP) of Gabon in 1995?
Your response must be concise. 0.04. What is the difference between the Mineral Rent(as % of GDP) of Caribbean small states in 1990 and the Mineral Rent(as % of GDP) of Bulgaria in 1996?
Your answer should be compact. 0.85. What is the difference between the Mineral Rent(as % of GDP) of Caribbean small states in 1990 and the Mineral Rent(as % of GDP) of Central African Republic in 1996?
Ensure brevity in your answer.  2.14. What is the difference between the Mineral Rent(as % of GDP) of Caribbean small states in 1990 and the Mineral Rent(as % of GDP) of Gabon in 1996?
Provide a short and direct response. 2.15. What is the difference between the Mineral Rent(as % of GDP) in Bulgaria in 1990 and the Mineral Rent(as % of GDP) in Central African Republic in 1996?
Provide a short and direct response. 0.37. What is the difference between the Mineral Rent(as % of GDP) in Bulgaria in 1990 and the Mineral Rent(as % of GDP) in Gabon in 1996?
Provide a short and direct response. 0.38. What is the difference between the Mineral Rent(as % of GDP) in Central African Republic in 1990 and the Mineral Rent(as % of GDP) in Gabon in 1996?
Your answer should be very brief. 0.04. What is the difference between the Mineral Rent(as % of GDP) in Caribbean small states in 1991 and the Mineral Rent(as % of GDP) in Bulgaria in 1995?
Offer a terse response. 1.23. What is the difference between the Mineral Rent(as % of GDP) of Caribbean small states in 1991 and the Mineral Rent(as % of GDP) of Central African Republic in 1995?
Offer a very short reply. 2.41. What is the difference between the Mineral Rent(as % of GDP) in Caribbean small states in 1991 and the Mineral Rent(as % of GDP) in Gabon in 1995?
Offer a terse response. 2.42. What is the difference between the Mineral Rent(as % of GDP) in Bulgaria in 1991 and the Mineral Rent(as % of GDP) in Central African Republic in 1995?
Offer a very short reply. 0.66. What is the difference between the Mineral Rent(as % of GDP) in Bulgaria in 1991 and the Mineral Rent(as % of GDP) in Gabon in 1995?
Keep it short and to the point. 0.67. What is the difference between the Mineral Rent(as % of GDP) of Central African Republic in 1991 and the Mineral Rent(as % of GDP) of Gabon in 1995?
Provide a short and direct response. 0.03. What is the difference between the Mineral Rent(as % of GDP) in Caribbean small states in 1991 and the Mineral Rent(as % of GDP) in Bulgaria in 1996?
Offer a very short reply. 1.12. What is the difference between the Mineral Rent(as % of GDP) in Caribbean small states in 1991 and the Mineral Rent(as % of GDP) in Central African Republic in 1996?
Keep it short and to the point. 2.41. What is the difference between the Mineral Rent(as % of GDP) of Caribbean small states in 1991 and the Mineral Rent(as % of GDP) of Gabon in 1996?
Give a very brief answer. 2.42. What is the difference between the Mineral Rent(as % of GDP) in Bulgaria in 1991 and the Mineral Rent(as % of GDP) in Central African Republic in 1996?
Your answer should be compact. 0.66. What is the difference between the Mineral Rent(as % of GDP) of Bulgaria in 1991 and the Mineral Rent(as % of GDP) of Gabon in 1996?
Offer a very short reply. 0.67. What is the difference between the Mineral Rent(as % of GDP) in Central African Republic in 1991 and the Mineral Rent(as % of GDP) in Gabon in 1996?
Ensure brevity in your answer.  0.03. What is the difference between the Mineral Rent(as % of GDP) of Caribbean small states in 1995 and the Mineral Rent(as % of GDP) of Bulgaria in 1996?
Offer a terse response. -0.4. What is the difference between the Mineral Rent(as % of GDP) of Caribbean small states in 1995 and the Mineral Rent(as % of GDP) of Central African Republic in 1996?
Offer a terse response. 0.89. What is the difference between the Mineral Rent(as % of GDP) of Caribbean small states in 1995 and the Mineral Rent(as % of GDP) of Gabon in 1996?
Give a very brief answer. 0.9. What is the difference between the Mineral Rent(as % of GDP) of Bulgaria in 1995 and the Mineral Rent(as % of GDP) of Central African Republic in 1996?
Make the answer very short. 1.18. What is the difference between the Mineral Rent(as % of GDP) of Bulgaria in 1995 and the Mineral Rent(as % of GDP) of Gabon in 1996?
Offer a very short reply. 1.19. What is the difference between the Mineral Rent(as % of GDP) in Central African Republic in 1995 and the Mineral Rent(as % of GDP) in Gabon in 1996?
Make the answer very short. 0.01. What is the average Mineral Rent(as % of GDP) in Caribbean small states per year?
Ensure brevity in your answer.  1.78. What is the average Mineral Rent(as % of GDP) of Bulgaria per year?
Ensure brevity in your answer.  1.05. What is the average Mineral Rent(as % of GDP) in Central African Republic per year?
Keep it short and to the point. 0.06. What is the average Mineral Rent(as % of GDP) in Gabon per year?
Offer a terse response. 0.01. In the year 1986, what is the difference between the Mineral Rent(as % of GDP) in Caribbean small states and Mineral Rent(as % of GDP) in Bulgaria?
Keep it short and to the point. 2.13. In the year 1986, what is the difference between the Mineral Rent(as % of GDP) of Caribbean small states and Mineral Rent(as % of GDP) of Central African Republic?
Make the answer very short. 2.21. In the year 1986, what is the difference between the Mineral Rent(as % of GDP) of Caribbean small states and Mineral Rent(as % of GDP) of Gabon?
Your response must be concise. 2.26. In the year 1986, what is the difference between the Mineral Rent(as % of GDP) in Bulgaria and Mineral Rent(as % of GDP) in Central African Republic?
Your answer should be compact. 0.08. In the year 1986, what is the difference between the Mineral Rent(as % of GDP) in Bulgaria and Mineral Rent(as % of GDP) in Gabon?
Offer a terse response. 0.13. In the year 1986, what is the difference between the Mineral Rent(as % of GDP) of Central African Republic and Mineral Rent(as % of GDP) of Gabon?
Provide a succinct answer. 0.05. In the year 1987, what is the difference between the Mineral Rent(as % of GDP) of Caribbean small states and Mineral Rent(as % of GDP) of Bulgaria?
Provide a short and direct response. 1.51. In the year 1987, what is the difference between the Mineral Rent(as % of GDP) of Caribbean small states and Mineral Rent(as % of GDP) of Central African Republic?
Offer a very short reply. 1.57. In the year 1987, what is the difference between the Mineral Rent(as % of GDP) in Caribbean small states and Mineral Rent(as % of GDP) in Gabon?
Offer a terse response. 1.66. In the year 1987, what is the difference between the Mineral Rent(as % of GDP) of Bulgaria and Mineral Rent(as % of GDP) of Central African Republic?
Your answer should be very brief. 0.07. In the year 1987, what is the difference between the Mineral Rent(as % of GDP) in Bulgaria and Mineral Rent(as % of GDP) in Gabon?
Offer a terse response. 0.15. In the year 1987, what is the difference between the Mineral Rent(as % of GDP) of Central African Republic and Mineral Rent(as % of GDP) of Gabon?
Offer a terse response. 0.08. In the year 1988, what is the difference between the Mineral Rent(as % of GDP) of Caribbean small states and Mineral Rent(as % of GDP) of Bulgaria?
Give a very brief answer. -0.9. In the year 1988, what is the difference between the Mineral Rent(as % of GDP) of Caribbean small states and Mineral Rent(as % of GDP) of Central African Republic?
Offer a very short reply. 1.38. In the year 1988, what is the difference between the Mineral Rent(as % of GDP) in Caribbean small states and Mineral Rent(as % of GDP) in Gabon?
Give a very brief answer. 1.49. In the year 1988, what is the difference between the Mineral Rent(as % of GDP) of Bulgaria and Mineral Rent(as % of GDP) of Central African Republic?
Provide a succinct answer. 2.28. In the year 1988, what is the difference between the Mineral Rent(as % of GDP) of Bulgaria and Mineral Rent(as % of GDP) of Gabon?
Keep it short and to the point. 2.39. In the year 1988, what is the difference between the Mineral Rent(as % of GDP) in Central African Republic and Mineral Rent(as % of GDP) in Gabon?
Offer a very short reply. 0.11. In the year 1989, what is the difference between the Mineral Rent(as % of GDP) of Caribbean small states and Mineral Rent(as % of GDP) of Bulgaria?
Provide a succinct answer. -0.06. In the year 1989, what is the difference between the Mineral Rent(as % of GDP) in Caribbean small states and Mineral Rent(as % of GDP) in Central African Republic?
Make the answer very short. 2.05. In the year 1989, what is the difference between the Mineral Rent(as % of GDP) of Caribbean small states and Mineral Rent(as % of GDP) of Gabon?
Ensure brevity in your answer.  2.11. In the year 1989, what is the difference between the Mineral Rent(as % of GDP) in Bulgaria and Mineral Rent(as % of GDP) in Central African Republic?
Your answer should be compact. 2.11. In the year 1989, what is the difference between the Mineral Rent(as % of GDP) of Bulgaria and Mineral Rent(as % of GDP) of Gabon?
Keep it short and to the point. 2.17. In the year 1989, what is the difference between the Mineral Rent(as % of GDP) in Central African Republic and Mineral Rent(as % of GDP) in Gabon?
Give a very brief answer. 0.06. In the year 1990, what is the difference between the Mineral Rent(as % of GDP) in Caribbean small states and Mineral Rent(as % of GDP) in Bulgaria?
Offer a very short reply. 1.77. In the year 1990, what is the difference between the Mineral Rent(as % of GDP) in Caribbean small states and Mineral Rent(as % of GDP) in Central African Republic?
Make the answer very short. 2.11. In the year 1990, what is the difference between the Mineral Rent(as % of GDP) in Caribbean small states and Mineral Rent(as % of GDP) in Gabon?
Make the answer very short. 2.15. In the year 1990, what is the difference between the Mineral Rent(as % of GDP) in Bulgaria and Mineral Rent(as % of GDP) in Central African Republic?
Ensure brevity in your answer.  0.34. In the year 1990, what is the difference between the Mineral Rent(as % of GDP) of Bulgaria and Mineral Rent(as % of GDP) of Gabon?
Offer a terse response. 0.38. In the year 1990, what is the difference between the Mineral Rent(as % of GDP) of Central African Republic and Mineral Rent(as % of GDP) of Gabon?
Provide a succinct answer. 0.04. In the year 1991, what is the difference between the Mineral Rent(as % of GDP) in Caribbean small states and Mineral Rent(as % of GDP) in Bulgaria?
Keep it short and to the point. 1.75. In the year 1991, what is the difference between the Mineral Rent(as % of GDP) of Caribbean small states and Mineral Rent(as % of GDP) of Central African Republic?
Provide a succinct answer. 2.39. In the year 1991, what is the difference between the Mineral Rent(as % of GDP) of Caribbean small states and Mineral Rent(as % of GDP) of Gabon?
Your answer should be very brief. 2.42. In the year 1991, what is the difference between the Mineral Rent(as % of GDP) in Bulgaria and Mineral Rent(as % of GDP) in Central African Republic?
Provide a short and direct response. 0.64. In the year 1991, what is the difference between the Mineral Rent(as % of GDP) in Bulgaria and Mineral Rent(as % of GDP) in Gabon?
Your answer should be compact. 0.67. In the year 1991, what is the difference between the Mineral Rent(as % of GDP) in Central African Republic and Mineral Rent(as % of GDP) in Gabon?
Provide a short and direct response. 0.03. In the year 1995, what is the difference between the Mineral Rent(as % of GDP) in Caribbean small states and Mineral Rent(as % of GDP) in Bulgaria?
Offer a very short reply. -0.29. In the year 1995, what is the difference between the Mineral Rent(as % of GDP) in Caribbean small states and Mineral Rent(as % of GDP) in Central African Republic?
Keep it short and to the point. 0.89. In the year 1995, what is the difference between the Mineral Rent(as % of GDP) of Caribbean small states and Mineral Rent(as % of GDP) of Gabon?
Your answer should be very brief. 0.9. In the year 1995, what is the difference between the Mineral Rent(as % of GDP) in Bulgaria and Mineral Rent(as % of GDP) in Central African Republic?
Your answer should be very brief. 1.18. In the year 1995, what is the difference between the Mineral Rent(as % of GDP) in Bulgaria and Mineral Rent(as % of GDP) in Gabon?
Provide a short and direct response. 1.19. In the year 1995, what is the difference between the Mineral Rent(as % of GDP) in Central African Republic and Mineral Rent(as % of GDP) in Gabon?
Make the answer very short. 0.01. In the year 1996, what is the difference between the Mineral Rent(as % of GDP) of Caribbean small states and Mineral Rent(as % of GDP) of Bulgaria?
Your answer should be very brief. -0.13. In the year 1996, what is the difference between the Mineral Rent(as % of GDP) in Caribbean small states and Mineral Rent(as % of GDP) in Central African Republic?
Give a very brief answer. 1.16. In the year 1996, what is the difference between the Mineral Rent(as % of GDP) in Caribbean small states and Mineral Rent(as % of GDP) in Gabon?
Your answer should be very brief. 1.17. In the year 1996, what is the difference between the Mineral Rent(as % of GDP) in Bulgaria and Mineral Rent(as % of GDP) in Central African Republic?
Offer a terse response. 1.29. In the year 1996, what is the difference between the Mineral Rent(as % of GDP) in Bulgaria and Mineral Rent(as % of GDP) in Gabon?
Offer a terse response. 1.3. In the year 1996, what is the difference between the Mineral Rent(as % of GDP) of Central African Republic and Mineral Rent(as % of GDP) of Gabon?
Keep it short and to the point. 0.01. What is the ratio of the Mineral Rent(as % of GDP) of Caribbean small states in 1986 to that in 1987?
Ensure brevity in your answer.  1.36. What is the ratio of the Mineral Rent(as % of GDP) in Bulgaria in 1986 to that in 1987?
Offer a terse response. 0.83. What is the ratio of the Mineral Rent(as % of GDP) in Central African Republic in 1986 to that in 1987?
Your answer should be very brief. 0.59. What is the ratio of the Mineral Rent(as % of GDP) of Gabon in 1986 to that in 1987?
Make the answer very short. 0.51. What is the ratio of the Mineral Rent(as % of GDP) of Caribbean small states in 1986 to that in 1988?
Provide a succinct answer. 1.5. What is the ratio of the Mineral Rent(as % of GDP) in Bulgaria in 1986 to that in 1988?
Offer a very short reply. 0.06. What is the ratio of the Mineral Rent(as % of GDP) of Central African Republic in 1986 to that in 1988?
Your answer should be very brief. 0.44. What is the ratio of the Mineral Rent(as % of GDP) of Gabon in 1986 to that in 1988?
Ensure brevity in your answer.  0.41. What is the ratio of the Mineral Rent(as % of GDP) in Caribbean small states in 1986 to that in 1989?
Keep it short and to the point. 1.07. What is the ratio of the Mineral Rent(as % of GDP) in Bulgaria in 1986 to that in 1989?
Provide a succinct answer. 0.06. What is the ratio of the Mineral Rent(as % of GDP) in Central African Republic in 1986 to that in 1989?
Make the answer very short. 0.85. What is the ratio of the Mineral Rent(as % of GDP) of Gabon in 1986 to that in 1989?
Provide a short and direct response. 1.28. What is the ratio of the Mineral Rent(as % of GDP) of Caribbean small states in 1986 to that in 1990?
Your answer should be very brief. 1.05. What is the ratio of the Mineral Rent(as % of GDP) of Bulgaria in 1986 to that in 1990?
Offer a terse response. 0.35. What is the ratio of the Mineral Rent(as % of GDP) in Central African Republic in 1986 to that in 1990?
Provide a succinct answer. 1.23. What is the ratio of the Mineral Rent(as % of GDP) of Gabon in 1986 to that in 1990?
Keep it short and to the point. 2.1. What is the ratio of the Mineral Rent(as % of GDP) in Caribbean small states in 1986 to that in 1991?
Your answer should be compact. 0.94. What is the ratio of the Mineral Rent(as % of GDP) of Bulgaria in 1986 to that in 1991?
Your answer should be compact. 0.2. What is the ratio of the Mineral Rent(as % of GDP) of Central African Republic in 1986 to that in 1991?
Your response must be concise. 2.01. What is the ratio of the Mineral Rent(as % of GDP) in Gabon in 1986 to that in 1991?
Give a very brief answer. 2.6. What is the ratio of the Mineral Rent(as % of GDP) in Caribbean small states in 1986 to that in 1995?
Your answer should be very brief. 2.51. What is the ratio of the Mineral Rent(as % of GDP) of Bulgaria in 1986 to that in 1995?
Keep it short and to the point. 0.11. What is the ratio of the Mineral Rent(as % of GDP) of Central African Republic in 1986 to that in 1995?
Offer a terse response. 5.95. What is the ratio of the Mineral Rent(as % of GDP) in Gabon in 1986 to that in 1995?
Ensure brevity in your answer.  4.03. What is the ratio of the Mineral Rent(as % of GDP) of Caribbean small states in 1986 to that in 1996?
Ensure brevity in your answer.  1.94. What is the ratio of the Mineral Rent(as % of GDP) in Bulgaria in 1986 to that in 1996?
Provide a succinct answer. 0.1. What is the ratio of the Mineral Rent(as % of GDP) in Central African Republic in 1986 to that in 1996?
Your response must be concise. 4.46. What is the ratio of the Mineral Rent(as % of GDP) in Gabon in 1986 to that in 1996?
Provide a succinct answer. 3.56. What is the ratio of the Mineral Rent(as % of GDP) of Caribbean small states in 1987 to that in 1988?
Make the answer very short. 1.11. What is the ratio of the Mineral Rent(as % of GDP) in Bulgaria in 1987 to that in 1988?
Ensure brevity in your answer.  0.07. What is the ratio of the Mineral Rent(as % of GDP) of Central African Republic in 1987 to that in 1988?
Provide a succinct answer. 0.75. What is the ratio of the Mineral Rent(as % of GDP) of Gabon in 1987 to that in 1988?
Ensure brevity in your answer.  0.8. What is the ratio of the Mineral Rent(as % of GDP) in Caribbean small states in 1987 to that in 1989?
Your answer should be very brief. 0.79. What is the ratio of the Mineral Rent(as % of GDP) of Bulgaria in 1987 to that in 1989?
Provide a succinct answer. 0.07. What is the ratio of the Mineral Rent(as % of GDP) in Central African Republic in 1987 to that in 1989?
Make the answer very short. 1.44. What is the ratio of the Mineral Rent(as % of GDP) of Gabon in 1987 to that in 1989?
Your answer should be very brief. 2.52. What is the ratio of the Mineral Rent(as % of GDP) in Caribbean small states in 1987 to that in 1990?
Provide a short and direct response. 0.78. What is the ratio of the Mineral Rent(as % of GDP) in Bulgaria in 1987 to that in 1990?
Provide a short and direct response. 0.42. What is the ratio of the Mineral Rent(as % of GDP) of Central African Republic in 1987 to that in 1990?
Your response must be concise. 2.09. What is the ratio of the Mineral Rent(as % of GDP) in Gabon in 1987 to that in 1990?
Your answer should be compact. 4.13. What is the ratio of the Mineral Rent(as % of GDP) of Caribbean small states in 1987 to that in 1991?
Ensure brevity in your answer.  0.69. What is the ratio of the Mineral Rent(as % of GDP) of Bulgaria in 1987 to that in 1991?
Offer a terse response. 0.24. What is the ratio of the Mineral Rent(as % of GDP) in Central African Republic in 1987 to that in 1991?
Provide a short and direct response. 3.41. What is the ratio of the Mineral Rent(as % of GDP) in Gabon in 1987 to that in 1991?
Provide a succinct answer. 5.12. What is the ratio of the Mineral Rent(as % of GDP) of Caribbean small states in 1987 to that in 1995?
Keep it short and to the point. 1.85. What is the ratio of the Mineral Rent(as % of GDP) in Bulgaria in 1987 to that in 1995?
Ensure brevity in your answer.  0.14. What is the ratio of the Mineral Rent(as % of GDP) in Central African Republic in 1987 to that in 1995?
Provide a succinct answer. 10.09. What is the ratio of the Mineral Rent(as % of GDP) in Gabon in 1987 to that in 1995?
Offer a very short reply. 7.92. What is the ratio of the Mineral Rent(as % of GDP) in Caribbean small states in 1987 to that in 1996?
Keep it short and to the point. 1.43. What is the ratio of the Mineral Rent(as % of GDP) of Bulgaria in 1987 to that in 1996?
Provide a short and direct response. 0.12. What is the ratio of the Mineral Rent(as % of GDP) in Central African Republic in 1987 to that in 1996?
Make the answer very short. 7.55. What is the ratio of the Mineral Rent(as % of GDP) of Gabon in 1987 to that in 1996?
Provide a succinct answer. 6.99. What is the ratio of the Mineral Rent(as % of GDP) of Caribbean small states in 1988 to that in 1989?
Keep it short and to the point. 0.71. What is the ratio of the Mineral Rent(as % of GDP) in Bulgaria in 1988 to that in 1989?
Keep it short and to the point. 1.1. What is the ratio of the Mineral Rent(as % of GDP) in Central African Republic in 1988 to that in 1989?
Offer a very short reply. 1.92. What is the ratio of the Mineral Rent(as % of GDP) in Gabon in 1988 to that in 1989?
Provide a succinct answer. 3.14. What is the ratio of the Mineral Rent(as % of GDP) of Caribbean small states in 1988 to that in 1990?
Your answer should be compact. 0.7. What is the ratio of the Mineral Rent(as % of GDP) in Bulgaria in 1988 to that in 1990?
Offer a terse response. 6.31. What is the ratio of the Mineral Rent(as % of GDP) in Central African Republic in 1988 to that in 1990?
Give a very brief answer. 2.79. What is the ratio of the Mineral Rent(as % of GDP) in Gabon in 1988 to that in 1990?
Provide a succinct answer. 5.15. What is the ratio of the Mineral Rent(as % of GDP) in Caribbean small states in 1988 to that in 1991?
Your response must be concise. 0.62. What is the ratio of the Mineral Rent(as % of GDP) in Bulgaria in 1988 to that in 1991?
Your response must be concise. 3.58. What is the ratio of the Mineral Rent(as % of GDP) of Central African Republic in 1988 to that in 1991?
Your response must be concise. 4.56. What is the ratio of the Mineral Rent(as % of GDP) in Gabon in 1988 to that in 1991?
Provide a short and direct response. 6.39. What is the ratio of the Mineral Rent(as % of GDP) of Caribbean small states in 1988 to that in 1995?
Offer a terse response. 1.67. What is the ratio of the Mineral Rent(as % of GDP) in Bulgaria in 1988 to that in 1995?
Ensure brevity in your answer.  2.02. What is the ratio of the Mineral Rent(as % of GDP) of Central African Republic in 1988 to that in 1995?
Your response must be concise. 13.47. What is the ratio of the Mineral Rent(as % of GDP) in Gabon in 1988 to that in 1995?
Your answer should be very brief. 9.89. What is the ratio of the Mineral Rent(as % of GDP) of Caribbean small states in 1988 to that in 1996?
Your answer should be compact. 1.29. What is the ratio of the Mineral Rent(as % of GDP) in Bulgaria in 1988 to that in 1996?
Provide a short and direct response. 1.84. What is the ratio of the Mineral Rent(as % of GDP) in Central African Republic in 1988 to that in 1996?
Your response must be concise. 10.09. What is the ratio of the Mineral Rent(as % of GDP) of Gabon in 1988 to that in 1996?
Keep it short and to the point. 8.73. What is the ratio of the Mineral Rent(as % of GDP) of Caribbean small states in 1989 to that in 1990?
Offer a very short reply. 0.98. What is the ratio of the Mineral Rent(as % of GDP) in Bulgaria in 1989 to that in 1990?
Give a very brief answer. 5.72. What is the ratio of the Mineral Rent(as % of GDP) in Central African Republic in 1989 to that in 1990?
Keep it short and to the point. 1.45. What is the ratio of the Mineral Rent(as % of GDP) in Gabon in 1989 to that in 1990?
Ensure brevity in your answer.  1.64. What is the ratio of the Mineral Rent(as % of GDP) of Caribbean small states in 1989 to that in 1991?
Give a very brief answer. 0.88. What is the ratio of the Mineral Rent(as % of GDP) of Bulgaria in 1989 to that in 1991?
Offer a terse response. 3.24. What is the ratio of the Mineral Rent(as % of GDP) of Central African Republic in 1989 to that in 1991?
Provide a succinct answer. 2.38. What is the ratio of the Mineral Rent(as % of GDP) of Gabon in 1989 to that in 1991?
Give a very brief answer. 2.03. What is the ratio of the Mineral Rent(as % of GDP) in Caribbean small states in 1989 to that in 1995?
Offer a terse response. 2.35. What is the ratio of the Mineral Rent(as % of GDP) of Bulgaria in 1989 to that in 1995?
Your response must be concise. 1.83. What is the ratio of the Mineral Rent(as % of GDP) in Central African Republic in 1989 to that in 1995?
Offer a terse response. 7.02. What is the ratio of the Mineral Rent(as % of GDP) of Gabon in 1989 to that in 1995?
Ensure brevity in your answer.  3.15. What is the ratio of the Mineral Rent(as % of GDP) in Caribbean small states in 1989 to that in 1996?
Provide a short and direct response. 1.81. What is the ratio of the Mineral Rent(as % of GDP) in Bulgaria in 1989 to that in 1996?
Offer a terse response. 1.67. What is the ratio of the Mineral Rent(as % of GDP) of Central African Republic in 1989 to that in 1996?
Make the answer very short. 5.26. What is the ratio of the Mineral Rent(as % of GDP) of Gabon in 1989 to that in 1996?
Offer a very short reply. 2.78. What is the ratio of the Mineral Rent(as % of GDP) in Caribbean small states in 1990 to that in 1991?
Give a very brief answer. 0.89. What is the ratio of the Mineral Rent(as % of GDP) in Bulgaria in 1990 to that in 1991?
Provide a short and direct response. 0.57. What is the ratio of the Mineral Rent(as % of GDP) in Central African Republic in 1990 to that in 1991?
Make the answer very short. 1.63. What is the ratio of the Mineral Rent(as % of GDP) of Gabon in 1990 to that in 1991?
Offer a terse response. 1.24. What is the ratio of the Mineral Rent(as % of GDP) in Caribbean small states in 1990 to that in 1995?
Provide a succinct answer. 2.39. What is the ratio of the Mineral Rent(as % of GDP) of Bulgaria in 1990 to that in 1995?
Your answer should be compact. 0.32. What is the ratio of the Mineral Rent(as % of GDP) of Central African Republic in 1990 to that in 1995?
Offer a terse response. 4.83. What is the ratio of the Mineral Rent(as % of GDP) of Gabon in 1990 to that in 1995?
Provide a succinct answer. 1.92. What is the ratio of the Mineral Rent(as % of GDP) in Caribbean small states in 1990 to that in 1996?
Offer a terse response. 1.84. What is the ratio of the Mineral Rent(as % of GDP) in Bulgaria in 1990 to that in 1996?
Give a very brief answer. 0.29. What is the ratio of the Mineral Rent(as % of GDP) of Central African Republic in 1990 to that in 1996?
Offer a very short reply. 3.62. What is the ratio of the Mineral Rent(as % of GDP) of Gabon in 1990 to that in 1996?
Offer a terse response. 1.7. What is the ratio of the Mineral Rent(as % of GDP) of Caribbean small states in 1991 to that in 1995?
Your answer should be compact. 2.68. What is the ratio of the Mineral Rent(as % of GDP) of Bulgaria in 1991 to that in 1995?
Offer a terse response. 0.57. What is the ratio of the Mineral Rent(as % of GDP) of Central African Republic in 1991 to that in 1995?
Give a very brief answer. 2.96. What is the ratio of the Mineral Rent(as % of GDP) of Gabon in 1991 to that in 1995?
Offer a terse response. 1.55. What is the ratio of the Mineral Rent(as % of GDP) in Caribbean small states in 1991 to that in 1996?
Offer a very short reply. 2.07. What is the ratio of the Mineral Rent(as % of GDP) of Bulgaria in 1991 to that in 1996?
Your answer should be compact. 0.52. What is the ratio of the Mineral Rent(as % of GDP) in Central African Republic in 1991 to that in 1996?
Provide a short and direct response. 2.21. What is the ratio of the Mineral Rent(as % of GDP) in Gabon in 1991 to that in 1996?
Offer a very short reply. 1.37. What is the ratio of the Mineral Rent(as % of GDP) in Caribbean small states in 1995 to that in 1996?
Ensure brevity in your answer.  0.77. What is the ratio of the Mineral Rent(as % of GDP) in Bulgaria in 1995 to that in 1996?
Your answer should be compact. 0.91. What is the ratio of the Mineral Rent(as % of GDP) of Central African Republic in 1995 to that in 1996?
Your answer should be very brief. 0.75. What is the ratio of the Mineral Rent(as % of GDP) of Gabon in 1995 to that in 1996?
Your response must be concise. 0.88. What is the difference between the highest and the second highest Mineral Rent(as % of GDP) of Caribbean small states?
Offer a terse response. 0.15. What is the difference between the highest and the second highest Mineral Rent(as % of GDP) in Bulgaria?
Provide a succinct answer. 0.23. What is the difference between the highest and the second highest Mineral Rent(as % of GDP) in Central African Republic?
Give a very brief answer. 0.03. What is the difference between the highest and the second highest Mineral Rent(as % of GDP) of Gabon?
Provide a short and direct response. 0. What is the difference between the highest and the lowest Mineral Rent(as % of GDP) in Caribbean small states?
Your answer should be very brief. 1.52. What is the difference between the highest and the lowest Mineral Rent(as % of GDP) in Bulgaria?
Your answer should be very brief. 2.27. What is the difference between the highest and the lowest Mineral Rent(as % of GDP) of Central African Republic?
Give a very brief answer. 0.12. What is the difference between the highest and the lowest Mineral Rent(as % of GDP) in Gabon?
Offer a very short reply. 0.01. 